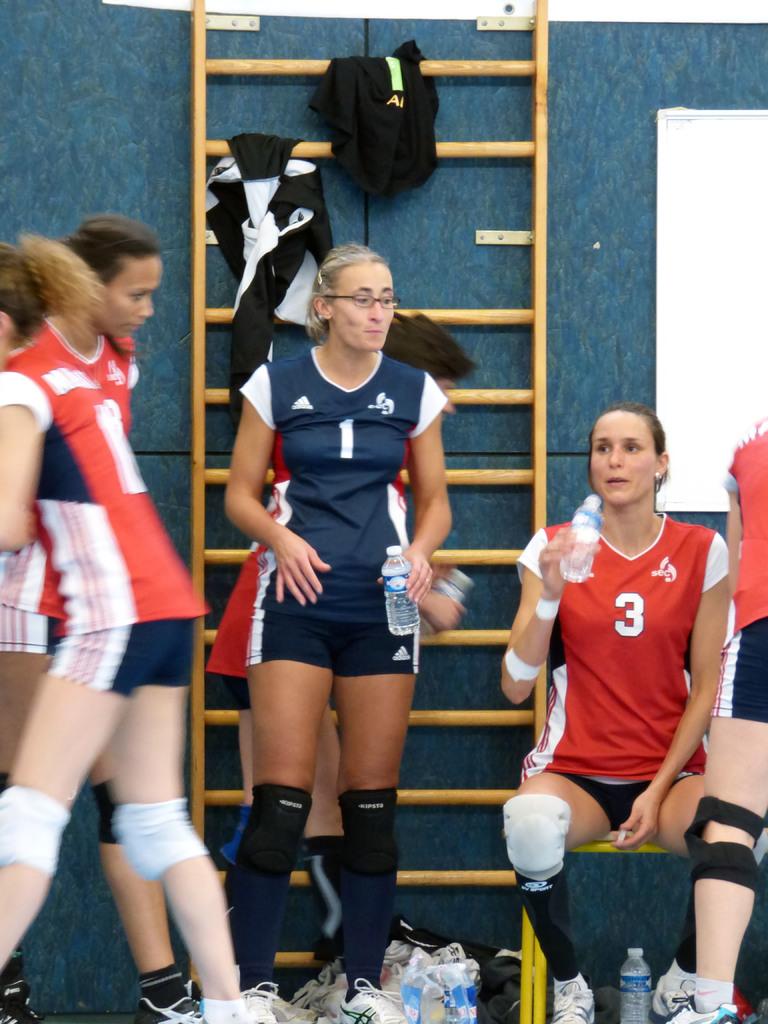Which player is wearing glasses?
Make the answer very short. 1. 